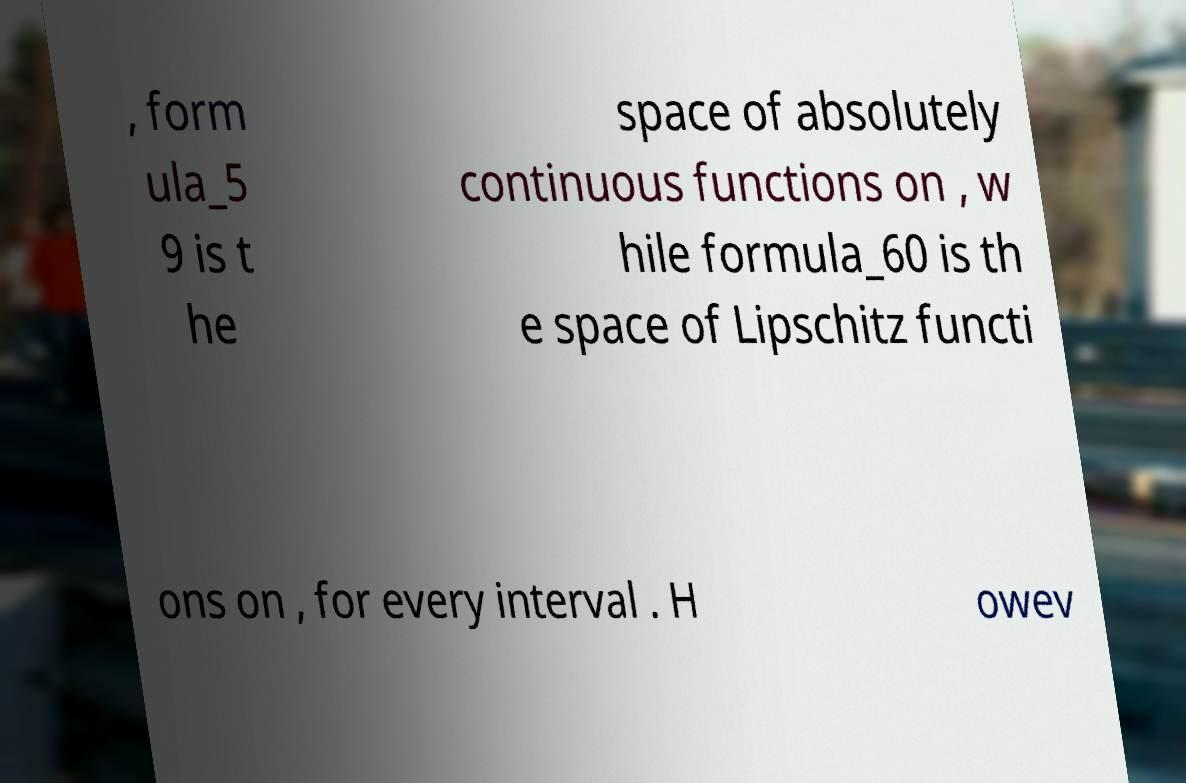What messages or text are displayed in this image? I need them in a readable, typed format. , form ula_5 9 is t he space of absolutely continuous functions on , w hile formula_60 is th e space of Lipschitz functi ons on , for every interval . H owev 